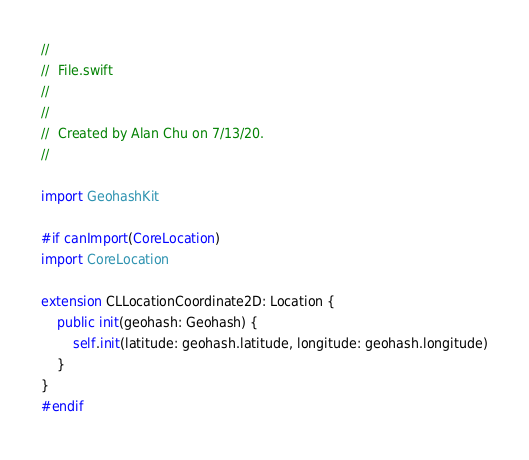<code> <loc_0><loc_0><loc_500><loc_500><_Swift_>//
//  File.swift
//  
//
//  Created by Alan Chu on 7/13/20.
//

import GeohashKit

#if canImport(CoreLocation)
import CoreLocation

extension CLLocationCoordinate2D: Location {
    public init(geohash: Geohash) {
        self.init(latitude: geohash.latitude, longitude: geohash.longitude)
    }
}
#endif
</code> 